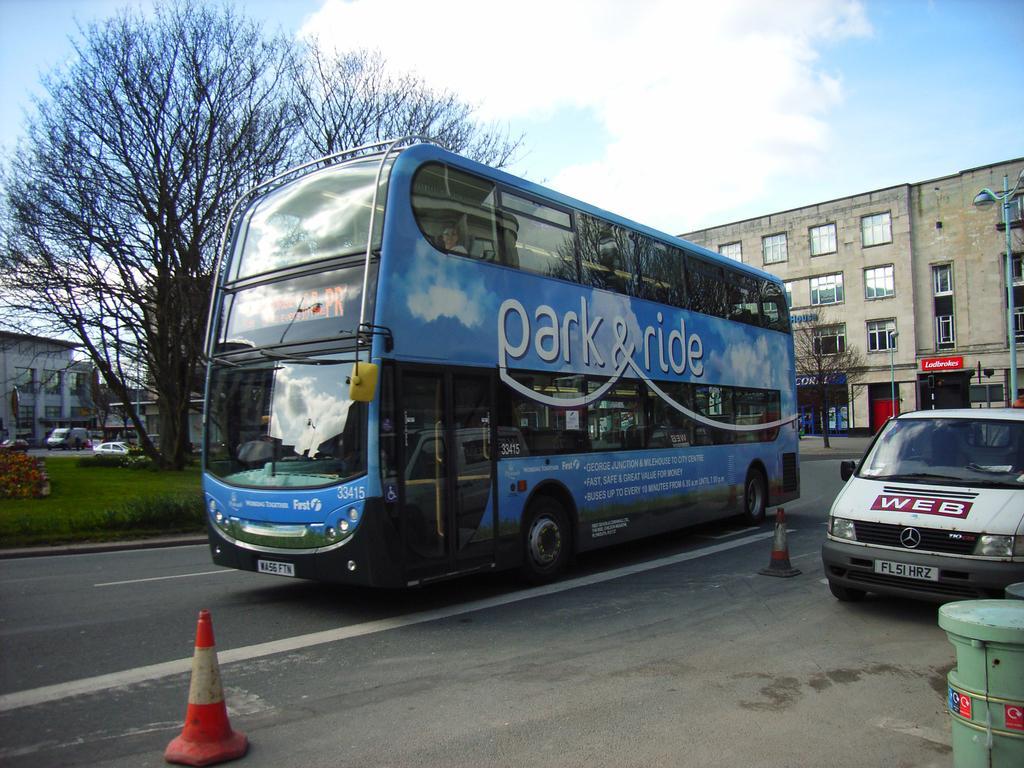In one or two sentences, can you explain what this image depicts? In this image there are some vehicles in the center, and there are barricades, walkway and some object. And in the background there are buildings, trees, poles, street lights, grass and some vehicles. At the top there is sky. 